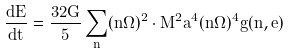Convert formula to latex. <formula><loc_0><loc_0><loc_500><loc_500>\frac { d E } { d t } = \frac { 3 2 G } { 5 } \sum _ { n } ( n \Omega ) ^ { 2 } \cdot M ^ { 2 } a ^ { 4 } ( n \Omega ) ^ { 4 } g ( n , e )</formula> 